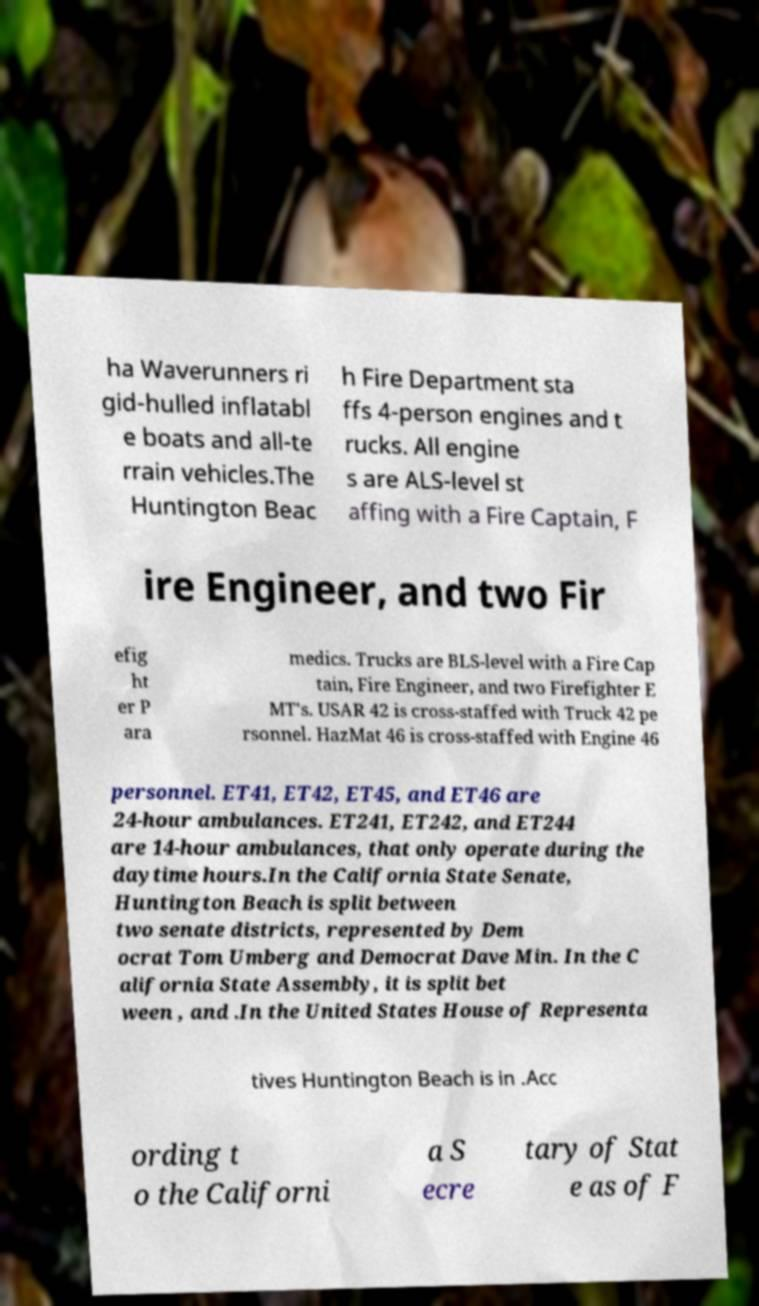Could you extract and type out the text from this image? ha Waverunners ri gid-hulled inflatabl e boats and all-te rrain vehicles.The Huntington Beac h Fire Department sta ffs 4-person engines and t rucks. All engine s are ALS-level st affing with a Fire Captain, F ire Engineer, and two Fir efig ht er P ara medics. Trucks are BLS-level with a Fire Cap tain, Fire Engineer, and two Firefighter E MT's. USAR 42 is cross-staffed with Truck 42 pe rsonnel. HazMat 46 is cross-staffed with Engine 46 personnel. ET41, ET42, ET45, and ET46 are 24-hour ambulances. ET241, ET242, and ET244 are 14-hour ambulances, that only operate during the daytime hours.In the California State Senate, Huntington Beach is split between two senate districts, represented by Dem ocrat Tom Umberg and Democrat Dave Min. In the C alifornia State Assembly, it is split bet ween , and .In the United States House of Representa tives Huntington Beach is in .Acc ording t o the Californi a S ecre tary of Stat e as of F 